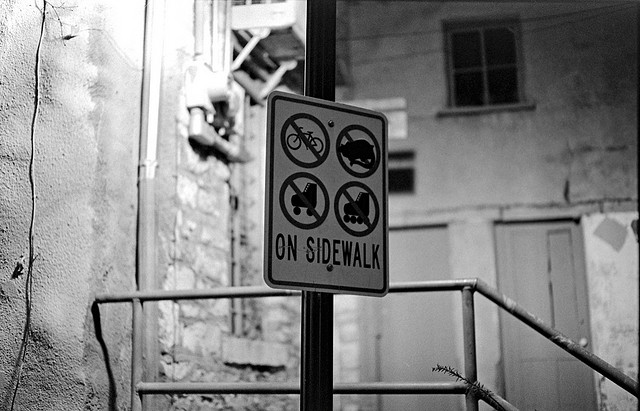<image>Is this sign in Quebec? I don't know if the sign is in Quebec. Is this sign in Quebec? I don't know if this sign is in Quebec or not. It is difficult to say for sure. 